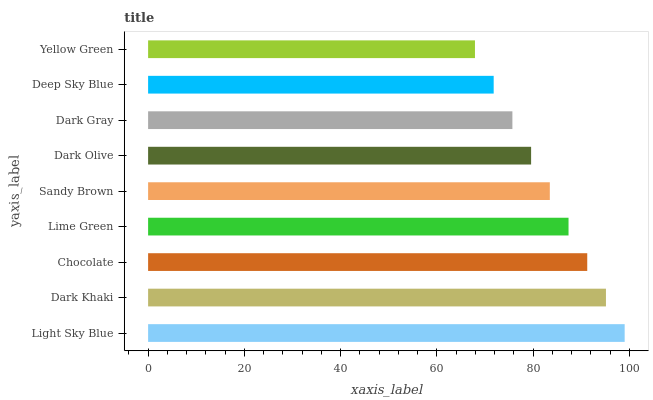Is Yellow Green the minimum?
Answer yes or no. Yes. Is Light Sky Blue the maximum?
Answer yes or no. Yes. Is Dark Khaki the minimum?
Answer yes or no. No. Is Dark Khaki the maximum?
Answer yes or no. No. Is Light Sky Blue greater than Dark Khaki?
Answer yes or no. Yes. Is Dark Khaki less than Light Sky Blue?
Answer yes or no. Yes. Is Dark Khaki greater than Light Sky Blue?
Answer yes or no. No. Is Light Sky Blue less than Dark Khaki?
Answer yes or no. No. Is Sandy Brown the high median?
Answer yes or no. Yes. Is Sandy Brown the low median?
Answer yes or no. Yes. Is Dark Khaki the high median?
Answer yes or no. No. Is Light Sky Blue the low median?
Answer yes or no. No. 